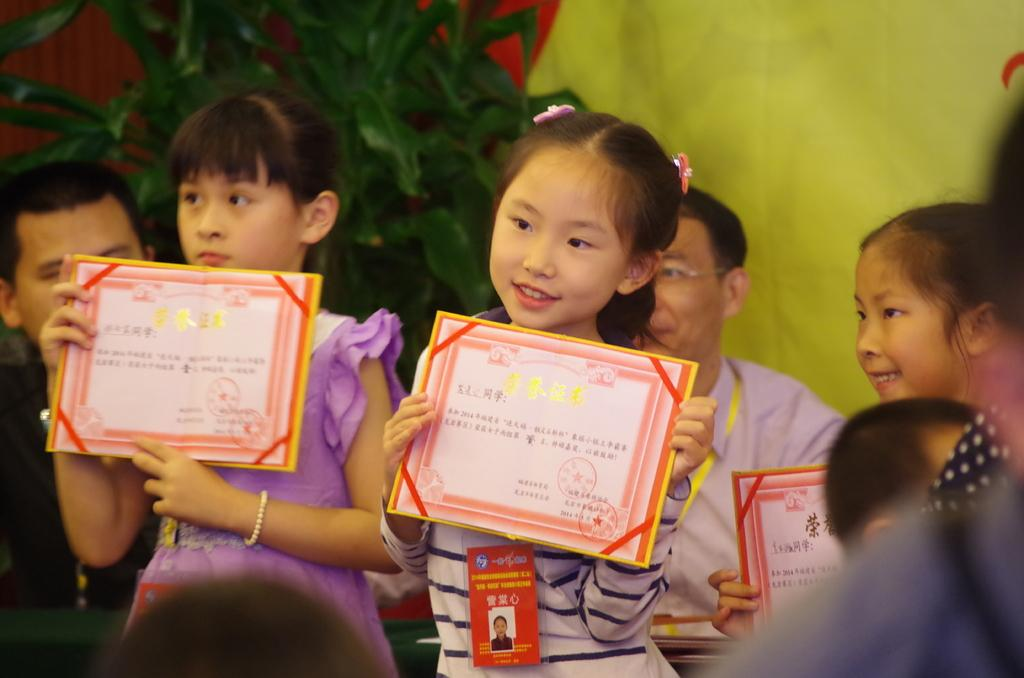Who is present in the image? There are girls in the image. What are the girls holding in their hands? The girls are holding objects in their hands. What can be seen in the background of the image? There are men and plants in the background of the image. Can you see any clouds in the image? There is no mention of clouds in the provided facts, so we cannot determine if any are present in the image. 